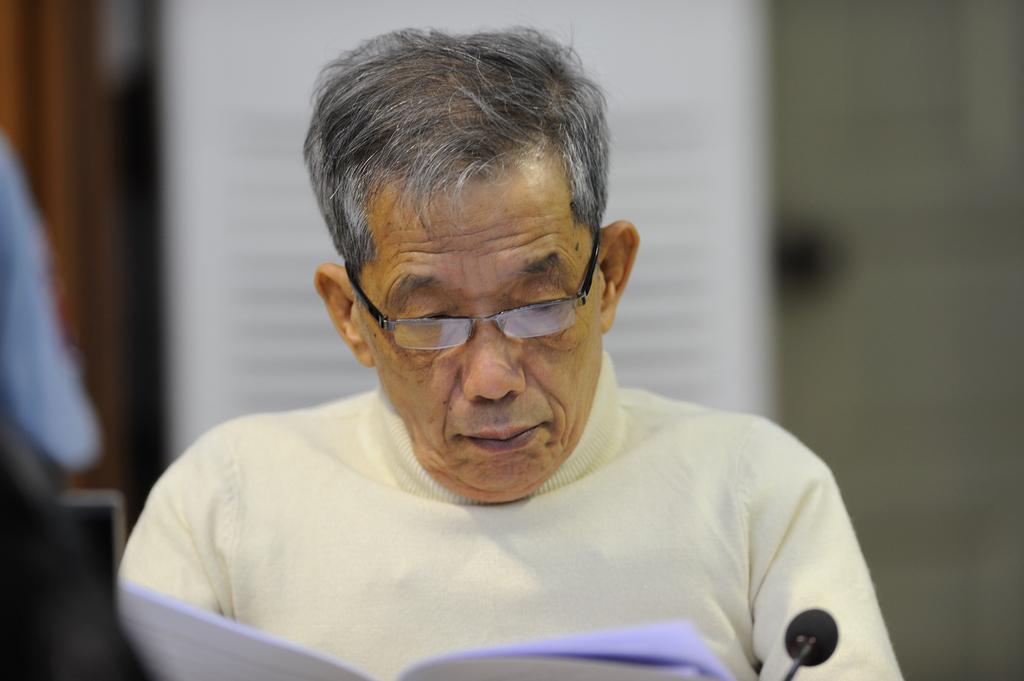Can you describe this image briefly? In this image there is a person sitting, there are papers truncated towards the bottom of the image, there is a microphone truncated towards the bottom of the image, there is an object truncated towards the left of the image, the background of the image is blurred. 